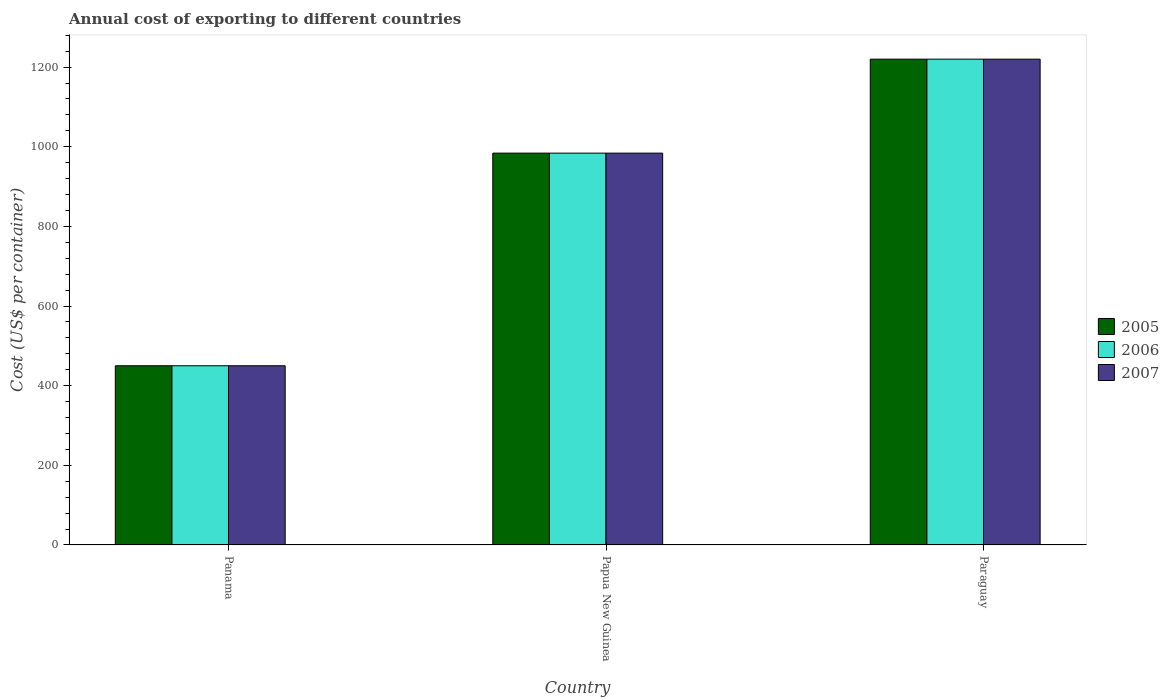How many different coloured bars are there?
Your answer should be compact. 3. Are the number of bars per tick equal to the number of legend labels?
Provide a succinct answer. Yes. What is the label of the 2nd group of bars from the left?
Offer a terse response. Papua New Guinea. In how many cases, is the number of bars for a given country not equal to the number of legend labels?
Your answer should be compact. 0. What is the total annual cost of exporting in 2007 in Paraguay?
Offer a very short reply. 1220. Across all countries, what is the maximum total annual cost of exporting in 2006?
Your answer should be compact. 1220. Across all countries, what is the minimum total annual cost of exporting in 2007?
Make the answer very short. 450. In which country was the total annual cost of exporting in 2006 maximum?
Your answer should be compact. Paraguay. In which country was the total annual cost of exporting in 2006 minimum?
Your answer should be very brief. Panama. What is the total total annual cost of exporting in 2006 in the graph?
Your response must be concise. 2654. What is the difference between the total annual cost of exporting in 2006 in Panama and that in Paraguay?
Offer a terse response. -770. What is the difference between the total annual cost of exporting in 2006 in Paraguay and the total annual cost of exporting in 2005 in Panama?
Offer a very short reply. 770. What is the average total annual cost of exporting in 2005 per country?
Give a very brief answer. 884.67. What is the ratio of the total annual cost of exporting in 2007 in Panama to that in Paraguay?
Keep it short and to the point. 0.37. What is the difference between the highest and the second highest total annual cost of exporting in 2006?
Ensure brevity in your answer.  534. What is the difference between the highest and the lowest total annual cost of exporting in 2005?
Your answer should be compact. 770. What does the 1st bar from the left in Panama represents?
Give a very brief answer. 2005. What does the 3rd bar from the right in Papua New Guinea represents?
Your response must be concise. 2005. How many bars are there?
Your response must be concise. 9. Are all the bars in the graph horizontal?
Your answer should be compact. No. Are the values on the major ticks of Y-axis written in scientific E-notation?
Keep it short and to the point. No. Does the graph contain grids?
Offer a very short reply. No. What is the title of the graph?
Offer a terse response. Annual cost of exporting to different countries. Does "1991" appear as one of the legend labels in the graph?
Give a very brief answer. No. What is the label or title of the Y-axis?
Give a very brief answer. Cost (US$ per container). What is the Cost (US$ per container) of 2005 in Panama?
Ensure brevity in your answer.  450. What is the Cost (US$ per container) of 2006 in Panama?
Provide a succinct answer. 450. What is the Cost (US$ per container) of 2007 in Panama?
Ensure brevity in your answer.  450. What is the Cost (US$ per container) in 2005 in Papua New Guinea?
Ensure brevity in your answer.  984. What is the Cost (US$ per container) of 2006 in Papua New Guinea?
Make the answer very short. 984. What is the Cost (US$ per container) in 2007 in Papua New Guinea?
Give a very brief answer. 984. What is the Cost (US$ per container) of 2005 in Paraguay?
Provide a short and direct response. 1220. What is the Cost (US$ per container) of 2006 in Paraguay?
Your answer should be very brief. 1220. What is the Cost (US$ per container) of 2007 in Paraguay?
Provide a short and direct response. 1220. Across all countries, what is the maximum Cost (US$ per container) in 2005?
Your response must be concise. 1220. Across all countries, what is the maximum Cost (US$ per container) in 2006?
Give a very brief answer. 1220. Across all countries, what is the maximum Cost (US$ per container) in 2007?
Ensure brevity in your answer.  1220. Across all countries, what is the minimum Cost (US$ per container) in 2005?
Your answer should be compact. 450. Across all countries, what is the minimum Cost (US$ per container) of 2006?
Ensure brevity in your answer.  450. Across all countries, what is the minimum Cost (US$ per container) in 2007?
Give a very brief answer. 450. What is the total Cost (US$ per container) in 2005 in the graph?
Make the answer very short. 2654. What is the total Cost (US$ per container) in 2006 in the graph?
Your answer should be compact. 2654. What is the total Cost (US$ per container) in 2007 in the graph?
Ensure brevity in your answer.  2654. What is the difference between the Cost (US$ per container) in 2005 in Panama and that in Papua New Guinea?
Give a very brief answer. -534. What is the difference between the Cost (US$ per container) in 2006 in Panama and that in Papua New Guinea?
Provide a succinct answer. -534. What is the difference between the Cost (US$ per container) of 2007 in Panama and that in Papua New Guinea?
Provide a succinct answer. -534. What is the difference between the Cost (US$ per container) of 2005 in Panama and that in Paraguay?
Your answer should be very brief. -770. What is the difference between the Cost (US$ per container) of 2006 in Panama and that in Paraguay?
Your answer should be very brief. -770. What is the difference between the Cost (US$ per container) in 2007 in Panama and that in Paraguay?
Offer a very short reply. -770. What is the difference between the Cost (US$ per container) of 2005 in Papua New Guinea and that in Paraguay?
Offer a terse response. -236. What is the difference between the Cost (US$ per container) in 2006 in Papua New Guinea and that in Paraguay?
Ensure brevity in your answer.  -236. What is the difference between the Cost (US$ per container) of 2007 in Papua New Guinea and that in Paraguay?
Your answer should be very brief. -236. What is the difference between the Cost (US$ per container) in 2005 in Panama and the Cost (US$ per container) in 2006 in Papua New Guinea?
Give a very brief answer. -534. What is the difference between the Cost (US$ per container) in 2005 in Panama and the Cost (US$ per container) in 2007 in Papua New Guinea?
Offer a very short reply. -534. What is the difference between the Cost (US$ per container) in 2006 in Panama and the Cost (US$ per container) in 2007 in Papua New Guinea?
Provide a succinct answer. -534. What is the difference between the Cost (US$ per container) in 2005 in Panama and the Cost (US$ per container) in 2006 in Paraguay?
Keep it short and to the point. -770. What is the difference between the Cost (US$ per container) in 2005 in Panama and the Cost (US$ per container) in 2007 in Paraguay?
Ensure brevity in your answer.  -770. What is the difference between the Cost (US$ per container) of 2006 in Panama and the Cost (US$ per container) of 2007 in Paraguay?
Offer a terse response. -770. What is the difference between the Cost (US$ per container) in 2005 in Papua New Guinea and the Cost (US$ per container) in 2006 in Paraguay?
Your response must be concise. -236. What is the difference between the Cost (US$ per container) in 2005 in Papua New Guinea and the Cost (US$ per container) in 2007 in Paraguay?
Keep it short and to the point. -236. What is the difference between the Cost (US$ per container) in 2006 in Papua New Guinea and the Cost (US$ per container) in 2007 in Paraguay?
Offer a terse response. -236. What is the average Cost (US$ per container) in 2005 per country?
Keep it short and to the point. 884.67. What is the average Cost (US$ per container) of 2006 per country?
Your response must be concise. 884.67. What is the average Cost (US$ per container) in 2007 per country?
Your response must be concise. 884.67. What is the difference between the Cost (US$ per container) of 2006 and Cost (US$ per container) of 2007 in Panama?
Make the answer very short. 0. What is the difference between the Cost (US$ per container) of 2005 and Cost (US$ per container) of 2006 in Papua New Guinea?
Your response must be concise. 0. What is the difference between the Cost (US$ per container) of 2006 and Cost (US$ per container) of 2007 in Papua New Guinea?
Provide a short and direct response. 0. What is the difference between the Cost (US$ per container) of 2005 and Cost (US$ per container) of 2006 in Paraguay?
Offer a very short reply. 0. What is the difference between the Cost (US$ per container) of 2005 and Cost (US$ per container) of 2007 in Paraguay?
Give a very brief answer. 0. What is the ratio of the Cost (US$ per container) of 2005 in Panama to that in Papua New Guinea?
Keep it short and to the point. 0.46. What is the ratio of the Cost (US$ per container) of 2006 in Panama to that in Papua New Guinea?
Keep it short and to the point. 0.46. What is the ratio of the Cost (US$ per container) in 2007 in Panama to that in Papua New Guinea?
Your answer should be compact. 0.46. What is the ratio of the Cost (US$ per container) in 2005 in Panama to that in Paraguay?
Provide a succinct answer. 0.37. What is the ratio of the Cost (US$ per container) in 2006 in Panama to that in Paraguay?
Ensure brevity in your answer.  0.37. What is the ratio of the Cost (US$ per container) in 2007 in Panama to that in Paraguay?
Make the answer very short. 0.37. What is the ratio of the Cost (US$ per container) in 2005 in Papua New Guinea to that in Paraguay?
Provide a short and direct response. 0.81. What is the ratio of the Cost (US$ per container) in 2006 in Papua New Guinea to that in Paraguay?
Offer a very short reply. 0.81. What is the ratio of the Cost (US$ per container) in 2007 in Papua New Guinea to that in Paraguay?
Provide a short and direct response. 0.81. What is the difference between the highest and the second highest Cost (US$ per container) in 2005?
Your response must be concise. 236. What is the difference between the highest and the second highest Cost (US$ per container) of 2006?
Keep it short and to the point. 236. What is the difference between the highest and the second highest Cost (US$ per container) of 2007?
Offer a very short reply. 236. What is the difference between the highest and the lowest Cost (US$ per container) of 2005?
Ensure brevity in your answer.  770. What is the difference between the highest and the lowest Cost (US$ per container) of 2006?
Provide a succinct answer. 770. What is the difference between the highest and the lowest Cost (US$ per container) of 2007?
Your response must be concise. 770. 